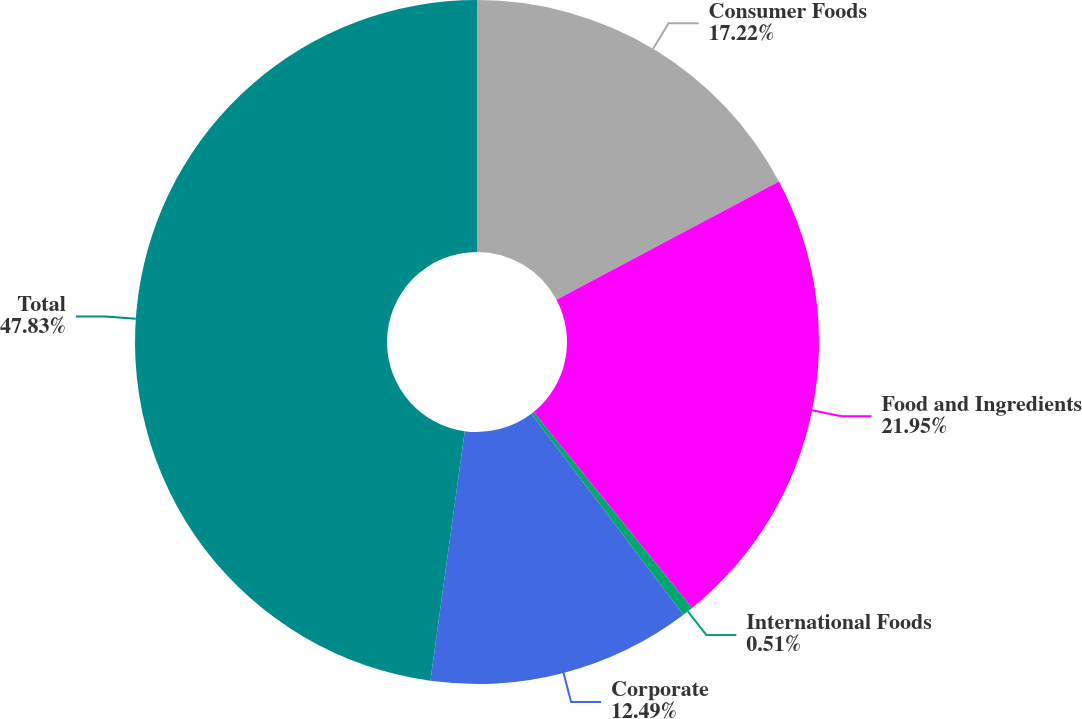Convert chart. <chart><loc_0><loc_0><loc_500><loc_500><pie_chart><fcel>Consumer Foods<fcel>Food and Ingredients<fcel>International Foods<fcel>Corporate<fcel>Total<nl><fcel>17.22%<fcel>21.95%<fcel>0.51%<fcel>12.49%<fcel>47.82%<nl></chart> 